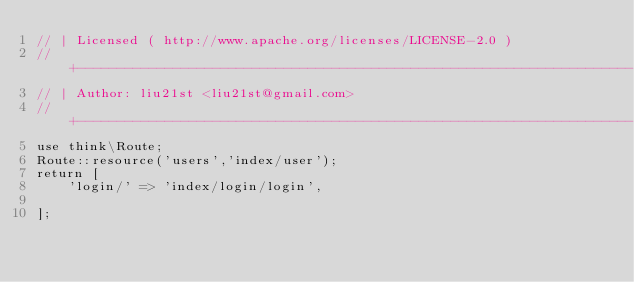Convert code to text. <code><loc_0><loc_0><loc_500><loc_500><_PHP_>// | Licensed ( http://www.apache.org/licenses/LICENSE-2.0 )
// +----------------------------------------------------------------------
// | Author: liu21st <liu21st@gmail.com>
// +----------------------------------------------------------------------
use think\Route;
Route::resource('users','index/user');
return [
    'login/' => 'index/login/login',

];
</code> 